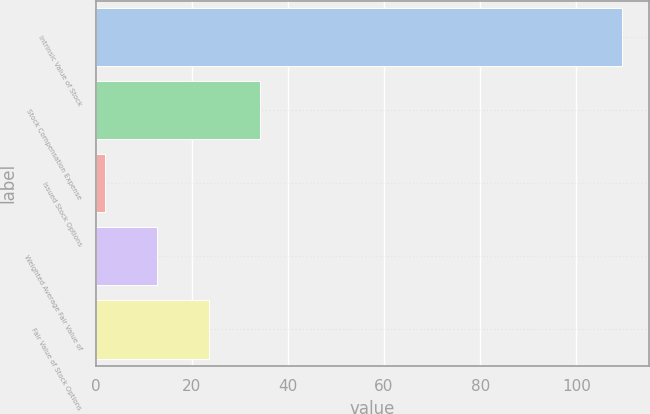Convert chart to OTSL. <chart><loc_0><loc_0><loc_500><loc_500><bar_chart><fcel>Intrinsic Value of Stock<fcel>Stock Compensation Expense<fcel>Issued Stock Options<fcel>Weighted Average Fair Value of<fcel>Fair Value of Stock Options<nl><fcel>109.6<fcel>34.28<fcel>2<fcel>12.76<fcel>23.52<nl></chart> 